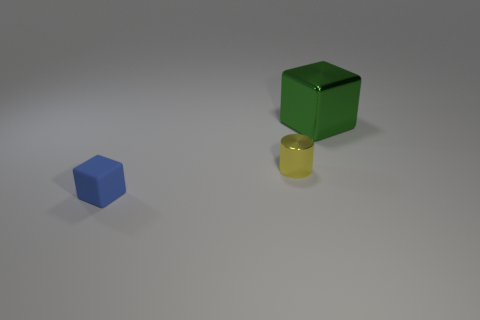Add 3 shiny blocks. How many objects exist? 6 Subtract all blocks. How many objects are left? 1 Subtract 1 yellow cylinders. How many objects are left? 2 Subtract all large green cubes. Subtract all tiny blue blocks. How many objects are left? 1 Add 3 small matte cubes. How many small matte cubes are left? 4 Add 3 big purple cylinders. How many big purple cylinders exist? 3 